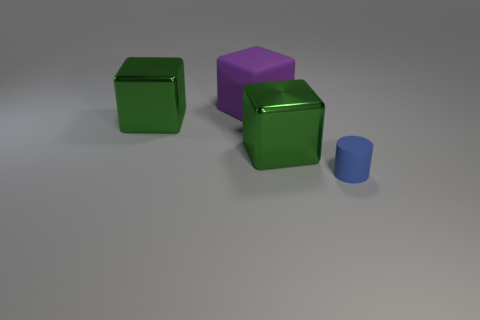Add 3 blue things. How many objects exist? 7 Subtract all large purple rubber blocks. How many blocks are left? 2 Subtract all cubes. How many objects are left? 1 Subtract all blue blocks. Subtract all cyan cylinders. How many blocks are left? 3 Add 4 balls. How many balls exist? 4 Subtract 1 green cubes. How many objects are left? 3 Subtract all blue matte objects. Subtract all tiny cyan metal objects. How many objects are left? 3 Add 3 big purple things. How many big purple things are left? 4 